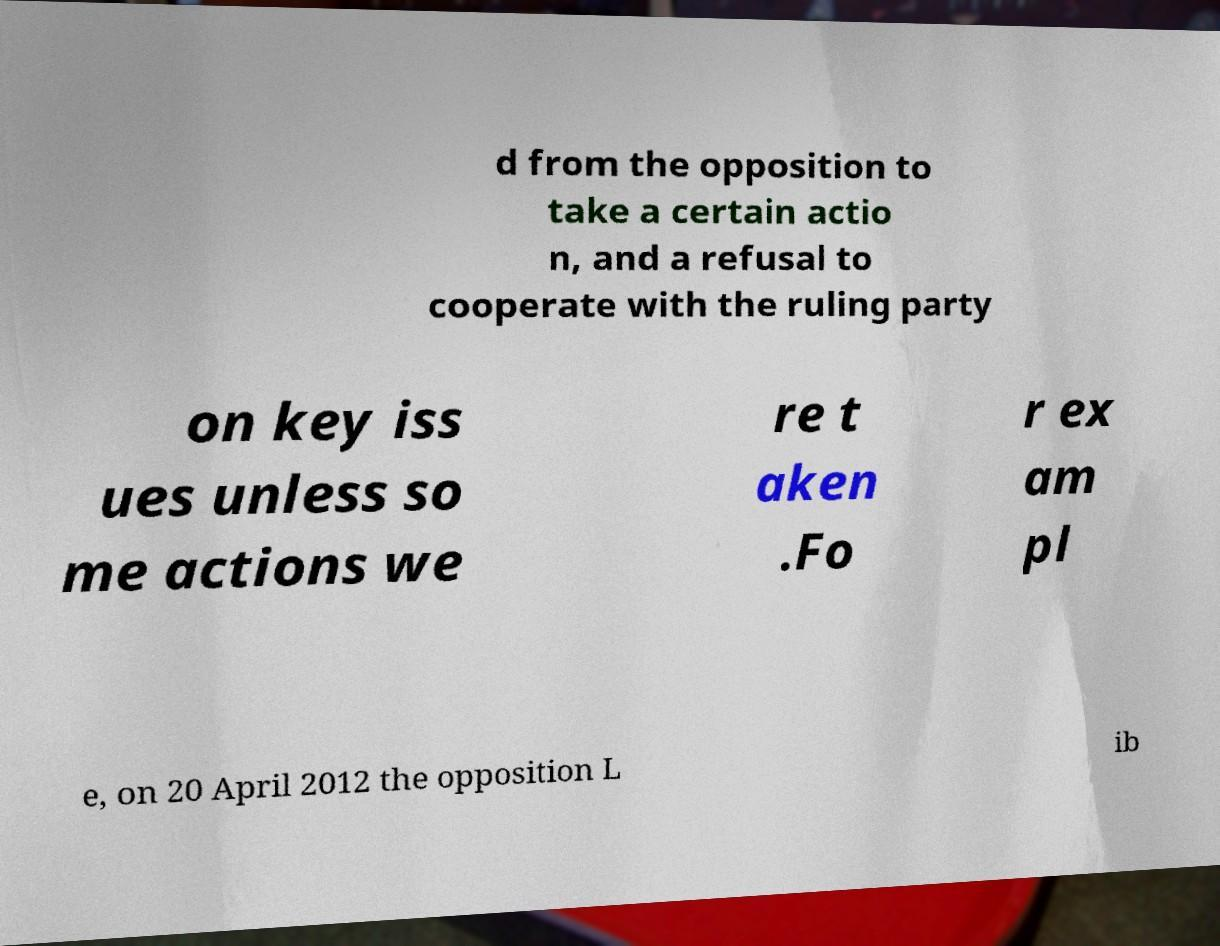I need the written content from this picture converted into text. Can you do that? d from the opposition to take a certain actio n, and a refusal to cooperate with the ruling party on key iss ues unless so me actions we re t aken .Fo r ex am pl e, on 20 April 2012 the opposition L ib 